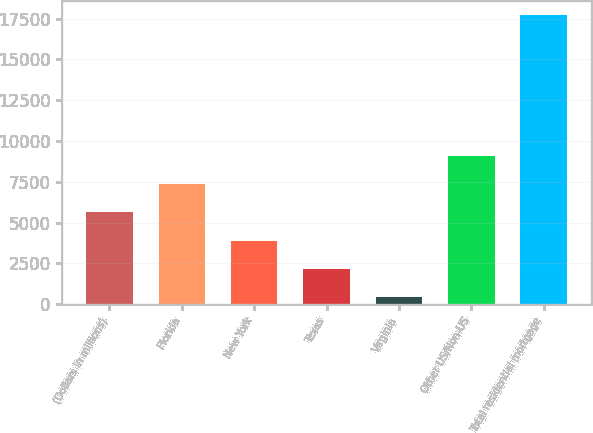Convert chart. <chart><loc_0><loc_0><loc_500><loc_500><bar_chart><fcel>(Dollars in millions)<fcel>Florida<fcel>New York<fcel>Texas<fcel>Virginia<fcel>Other US/Non-US<fcel>Total residential mortgage<nl><fcel>5622.3<fcel>7346.4<fcel>3898.2<fcel>2174.1<fcel>450<fcel>9070.5<fcel>17691<nl></chart> 